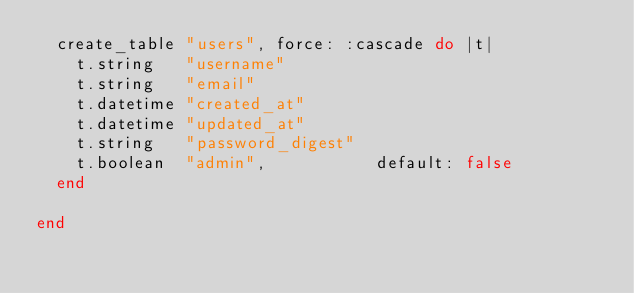<code> <loc_0><loc_0><loc_500><loc_500><_Ruby_>  create_table "users", force: :cascade do |t|
    t.string   "username"
    t.string   "email"
    t.datetime "created_at"
    t.datetime "updated_at"
    t.string   "password_digest"
    t.boolean  "admin",           default: false
  end

end
</code> 